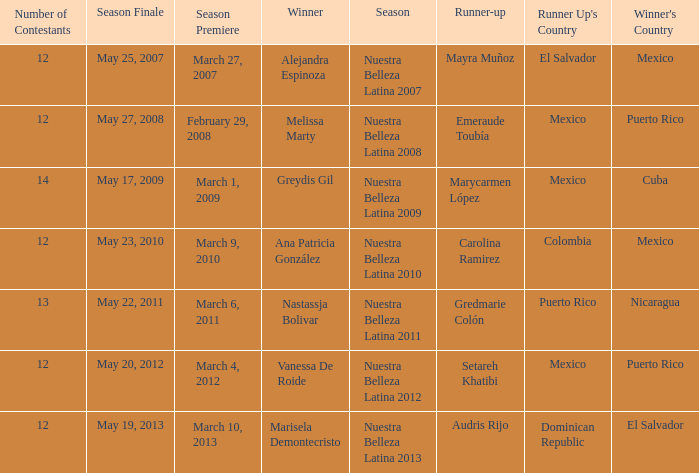What season's premiere had puerto rico winning on May 20, 2012? March 4, 2012. 